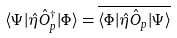<formula> <loc_0><loc_0><loc_500><loc_500>\langle \Psi | \hat { \eta } \hat { O } ^ { \dagger } _ { p } | \Phi \rangle = \overline { \langle \Phi | \hat { \eta } \hat { O } _ { p } | \Psi \rangle }</formula> 